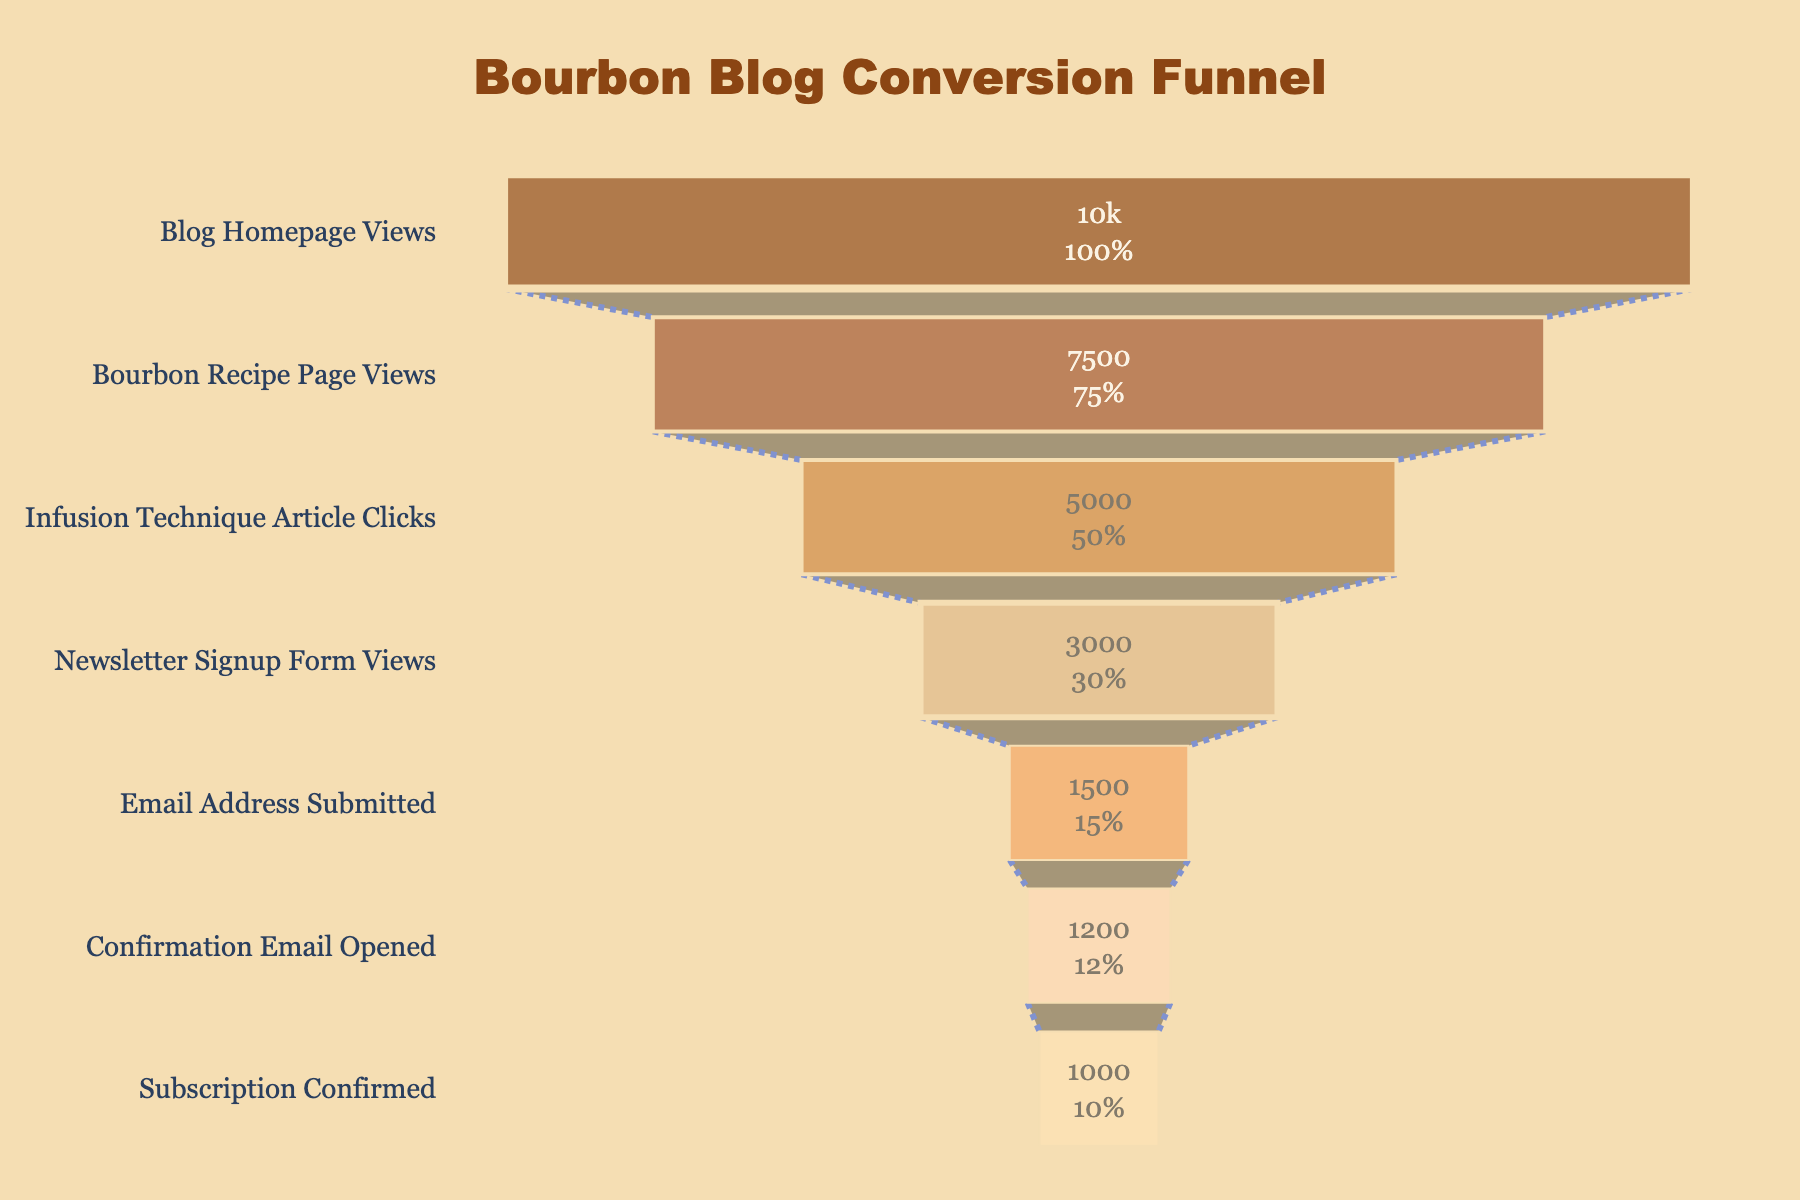What's the title of the funnel chart? The title of the funnel chart is prominently placed at the top and reads "Bourbon Blog Conversion Funnel". This is clearly visible in the figure.
Answer: Bourbon Blog Conversion Funnel How many stages are there in the funnel? To determine the number of stages in the funnel, count the distinct sections labeled on the y-axis. There are seven stages listed: Blog Homepage Views, Bourbon Recipe Page Views, Infusion Technique Article Clicks, Newsletter Signup Form Views, Email Address Submitted, Confirmation Email Opened, and Subscription Confirmed.
Answer: 7 What percentage of visitors reach the Newsletter Signup Form Views stage? Look at the text inside the "Newsletter Signup Form Views" section. This shows the value 3000, which represents 30% of the initial 10000 Blog Homepage Views.
Answer: 30% How many more visitors viewed the Blog Homepage compared to those who confirmed their subscription? Find the values for "Blog Homepage Views" and "Subscription Confirmed", which are 10000 and 1000, respectively. The difference is 10000 - 1000.
Answer: 9000 What is the percentage drop from Email Address Submitted to Confirmation Email Opened? Note the values for both stages: 1500 for Email Address Submitted and 1200 for Confirmation Email Opened. The percentage drop is calculated as ((1500 - 1200) / 1500) * 100%.
Answer: 20% Among the stages, which one has the smallest number of visitors? Review the visitor numbers for each stage and identify the stage with the lowest number. "Subscription Confirmed" shows 1000, which is the smallest number.
Answer: Subscription Confirmed What is the cumulative percentage drop from Blog Homepage Views to Subscription Confirmed? Start with Blog Homepage Views (10000) and end with Subscription Confirmed (1000). The cumulative percentage drop is calculated as ((10000 - 1000) / 10000) * 100%.
Answer: 90% Which stage experiences the largest drop in visitors? Compare the differences in the number of visitors between consecutive stages. The biggest drop is between "Bourbon Recipe Page Views" (7500) to "Infusion Technique Article Clicks" (5000), which is a drop of 2500 visitors.
Answer: Bourbon Recipe Page Views to Infusion Technique Article Clicks What percentage of visitors who view the Infusion Technique Article Clicks actually open the Confirmation Email? First, note the values for "Infusion Technique Article Clicks" (5000) and "Confirmation Email Opened" (1200). Calculate the percentage as (1200 / 5000) * 100%.
Answer: 24% How many stages include a transition involving less than 2000 visitors? Count the stages that have a visitor number decrease lesser than 2000 from the previous stage. Transition from Email Address Submitted (1500) to Confirmation Email Opened (1200), and Newsletter Signup Form Views (3000) to Email Address Submitted (1500) fit this criterion.
Answer: 2 